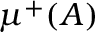<formula> <loc_0><loc_0><loc_500><loc_500>\mu ^ { + } ( A )</formula> 